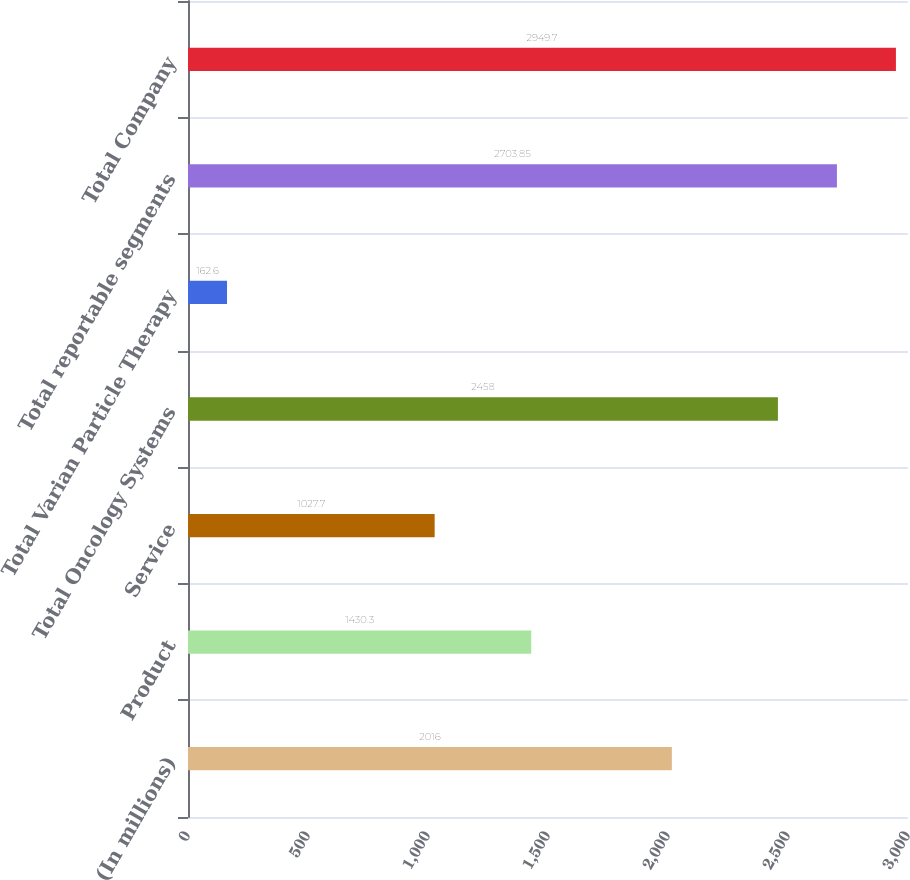<chart> <loc_0><loc_0><loc_500><loc_500><bar_chart><fcel>(In millions)<fcel>Product<fcel>Service<fcel>Total Oncology Systems<fcel>Total Varian Particle Therapy<fcel>Total reportable segments<fcel>Total Company<nl><fcel>2016<fcel>1430.3<fcel>1027.7<fcel>2458<fcel>162.6<fcel>2703.85<fcel>2949.7<nl></chart> 